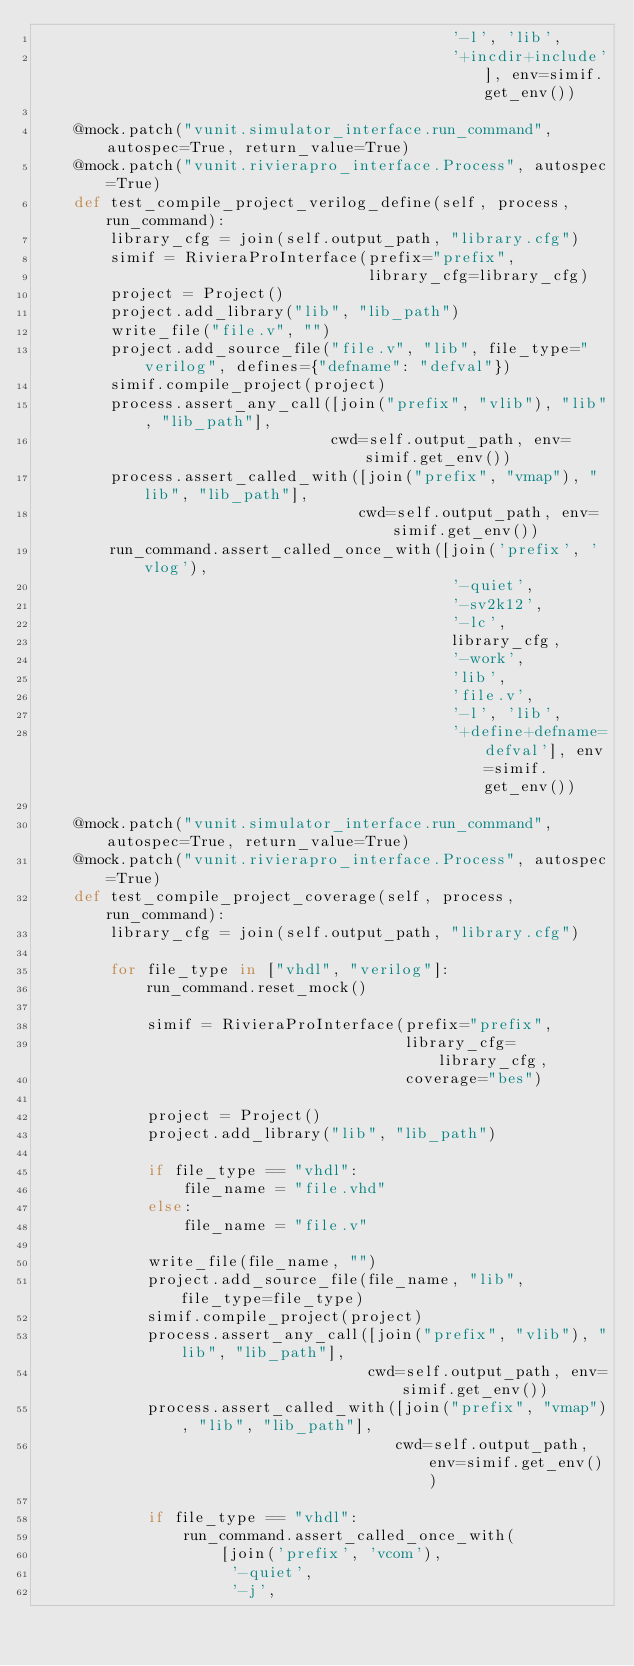Convert code to text. <code><loc_0><loc_0><loc_500><loc_500><_Python_>                                             '-l', 'lib',
                                             '+incdir+include'], env=simif.get_env())

    @mock.patch("vunit.simulator_interface.run_command", autospec=True, return_value=True)
    @mock.patch("vunit.rivierapro_interface.Process", autospec=True)
    def test_compile_project_verilog_define(self, process, run_command):
        library_cfg = join(self.output_path, "library.cfg")
        simif = RivieraProInterface(prefix="prefix",
                                    library_cfg=library_cfg)
        project = Project()
        project.add_library("lib", "lib_path")
        write_file("file.v", "")
        project.add_source_file("file.v", "lib", file_type="verilog", defines={"defname": "defval"})
        simif.compile_project(project)
        process.assert_any_call([join("prefix", "vlib"), "lib", "lib_path"],
                                cwd=self.output_path, env=simif.get_env())
        process.assert_called_with([join("prefix", "vmap"), "lib", "lib_path"],
                                   cwd=self.output_path, env=simif.get_env())
        run_command.assert_called_once_with([join('prefix', 'vlog'),
                                             '-quiet',
                                             '-sv2k12',
                                             '-lc',
                                             library_cfg,
                                             '-work',
                                             'lib',
                                             'file.v',
                                             '-l', 'lib',
                                             '+define+defname=defval'], env=simif.get_env())

    @mock.patch("vunit.simulator_interface.run_command", autospec=True, return_value=True)
    @mock.patch("vunit.rivierapro_interface.Process", autospec=True)
    def test_compile_project_coverage(self, process, run_command):
        library_cfg = join(self.output_path, "library.cfg")

        for file_type in ["vhdl", "verilog"]:
            run_command.reset_mock()

            simif = RivieraProInterface(prefix="prefix",
                                        library_cfg=library_cfg,
                                        coverage="bes")

            project = Project()
            project.add_library("lib", "lib_path")

            if file_type == "vhdl":
                file_name = "file.vhd"
            else:
                file_name = "file.v"

            write_file(file_name, "")
            project.add_source_file(file_name, "lib", file_type=file_type)
            simif.compile_project(project)
            process.assert_any_call([join("prefix", "vlib"), "lib", "lib_path"],
                                    cwd=self.output_path, env=simif.get_env())
            process.assert_called_with([join("prefix", "vmap"), "lib", "lib_path"],
                                       cwd=self.output_path, env=simif.get_env())

            if file_type == "vhdl":
                run_command.assert_called_once_with(
                    [join('prefix', 'vcom'),
                     '-quiet',
                     '-j',</code> 